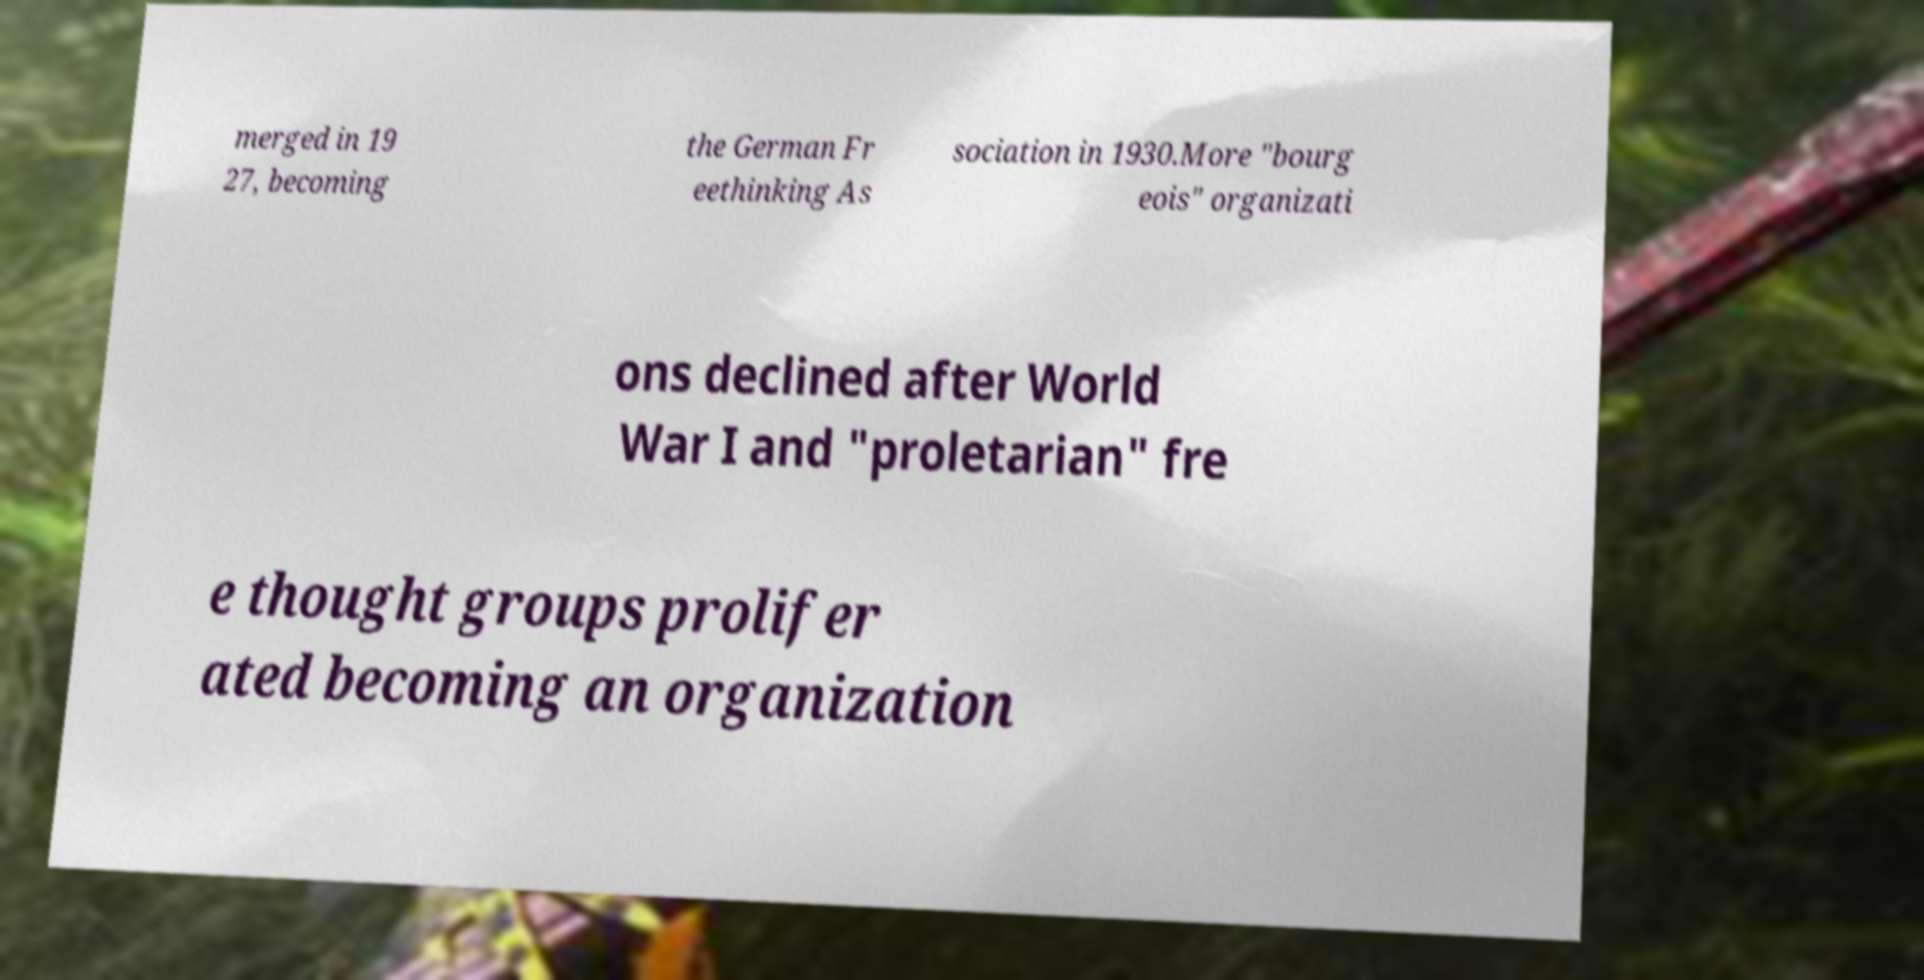Please read and relay the text visible in this image. What does it say? merged in 19 27, becoming the German Fr eethinking As sociation in 1930.More "bourg eois" organizati ons declined after World War I and "proletarian" fre e thought groups prolifer ated becoming an organization 